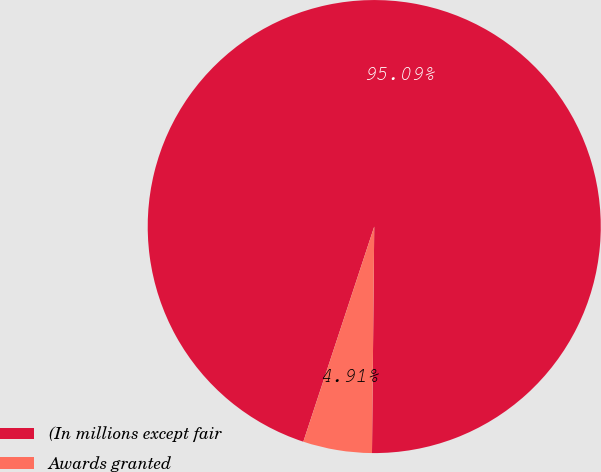Convert chart. <chart><loc_0><loc_0><loc_500><loc_500><pie_chart><fcel>(In millions except fair<fcel>Awards granted<nl><fcel>95.09%<fcel>4.91%<nl></chart> 